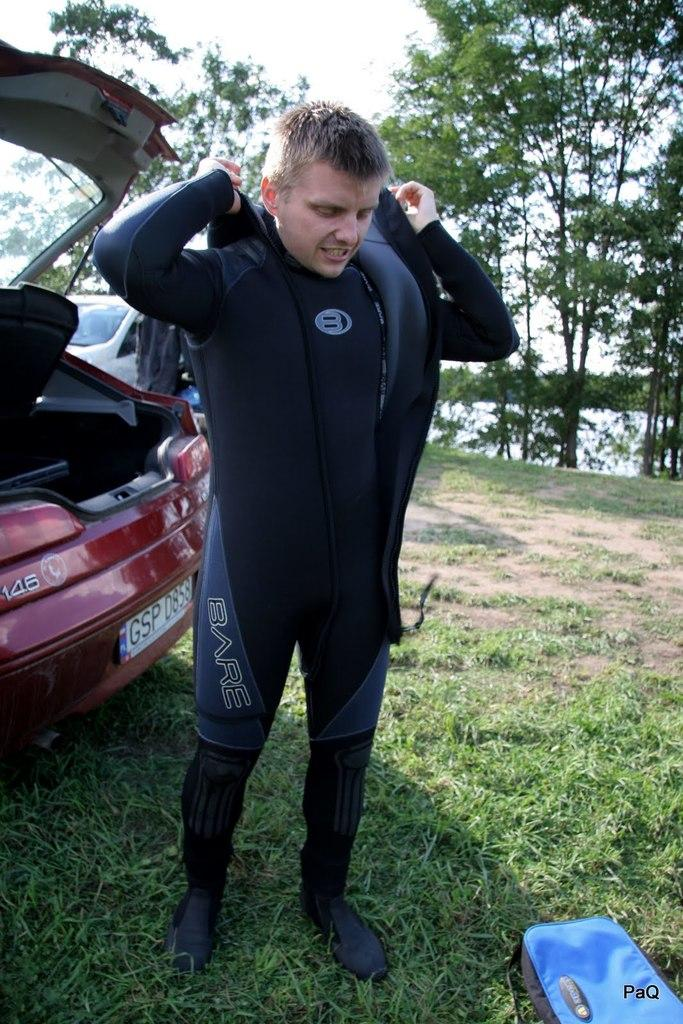What is the main subject of the image? There is a person standing in the image. Can you describe the person's attire? The person is wearing a black dress. What can be seen in the background of the image? There are cars and trees with green color in the background of the image. The sky is also visible, and it appears to be white in color. How many geese are flying in the image? There are no geese present in the image. What type of bait is being used by the person in the image? There is no indication of any fishing or bait in the image; it features a person standing in a black dress with a background of cars, trees, and a white sky. 